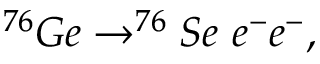<formula> <loc_0><loc_0><loc_500><loc_500>^ { 7 6 } G e \to ^ { 7 6 } S e \ e ^ { - } e ^ { - } ,</formula> 